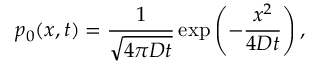<formula> <loc_0><loc_0><loc_500><loc_500>p _ { 0 } ( x , t ) = \frac { 1 } { \sqrt { 4 \pi D t } } \exp \left ( - \frac { x ^ { 2 } } { 4 D t } \right ) ,</formula> 